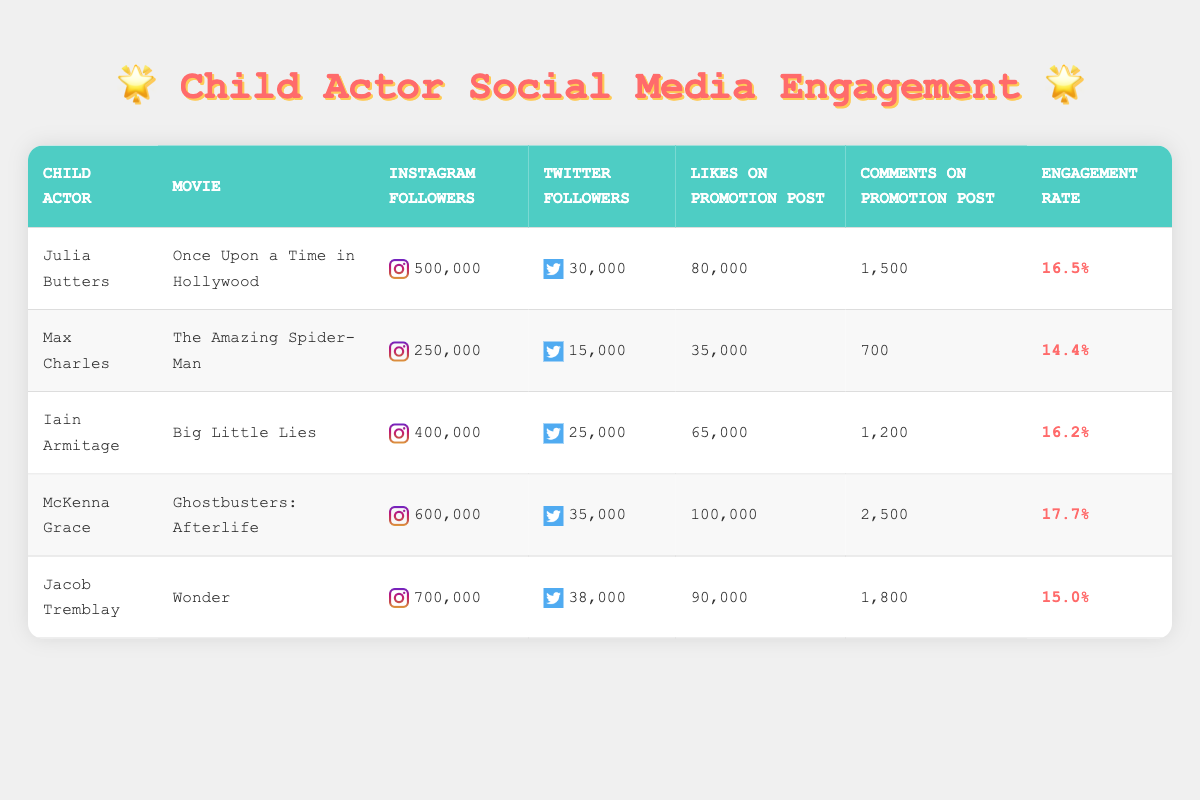What is the engagement rate for McKenna Grace? The engagement rate for McKenna Grace can be found in the table under the corresponding column for engagement rate. It shows 17.7%.
Answer: 17.7% How many Instagram followers does Jacob Tremblay have? The table lists Jacob Tremblay's Instagram followers in the column titled "Instagram Followers". The count is 700,000.
Answer: 700,000 Which child actor had the highest engagement rate? To identify the child actor with the highest engagement rate, I need to compare the engagement rates for each actor listed. McKenna Grace has the highest engagement rate at 17.7%.
Answer: McKenna Grace What is the total number of likes on promotion posts for all child actors combined? To find the total number of likes, I will sum the likes on promotion posts for each child actor: 80,000 + 35,000 + 65,000 + 100,000 + 90,000 = 370,000.
Answer: 370,000 Is it true that Iain Armitage has more Twitter followers than Julia Butters? Comparing the Twitter followers for each child actor, Julia Butters has 30,000 while Iain Armitage has 25,000, which means the statement is false.
Answer: No What is the average number of comments on promotion posts across all child actors? To calculate the average, I first sum the comments: 1500 + 700 + 1200 + 2500 + 1800 = 5700. Then I divide by the number of child actors, which is 5: 5700/5 = 1140.
Answer: 1140 Which child actor had the least number of likes on their promotion post? Looking at the "Likes on Promotion Post" column, Max Charles has the lowest number of likes with 35,000 compared to others.
Answer: Max Charles How many more Instagram followers does McKenna Grace have compared to Max Charles? To find the difference in Instagram followers, I subtract Max Charles's followers (250,000) from McKenna Grace's followers (600,000): 600,000 - 250,000 = 350,000.
Answer: 350,000 Is the engagement rate for Jacob Tremblay greater than 15%? Checking Jacob Tremblay's engagement rate in the table, it shows 15.0%, which is not greater than 15%. Therefore, the statement is false.
Answer: No 